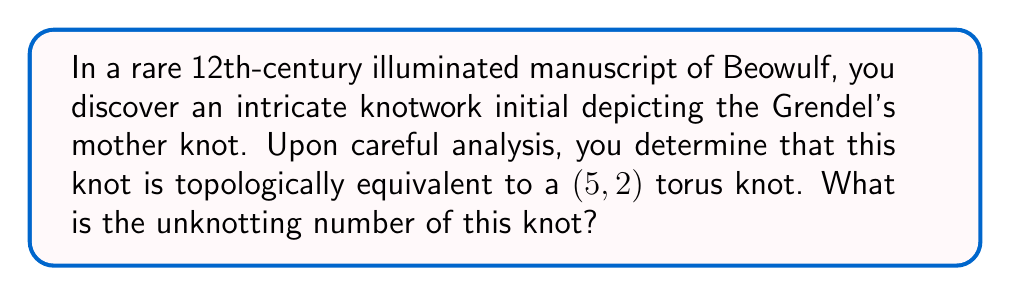Teach me how to tackle this problem. To determine the unknotting number of the (5,2) torus knot, we'll follow these steps:

1) First, recall that for a (p,q) torus knot, where p and q are coprime integers, the unknotting number u is given by the formula:

   $$u = \frac{(p-1)(q-1)}{2}$$

2) In this case, we have p = 5 and q = 2. Let's substitute these values:

   $$u = \frac{(5-1)(2-1)}{2}$$

3) Simplify:
   $$u = \frac{(4)(1)}{2} = \frac{4}{2}$$

4) Calculate the final result:
   $$u = 2$$

5) To understand this geometrically, we can visualize that it takes two crossing changes to unknot the (5,2) torus knot. Each crossing change reduces the number of twists around the longitudinal direction of the torus.

[asy]
import graph;
size(200);
pair A=(0,0), B=(2,0), C=(1,1.5);
draw(A--B--C--cycle);
draw((0.7,0.5)--(1.3,0.5), arrow=Arrow(TeXHead));
draw((1.3,1)--(0.7,1), arrow=Arrow(TeXHead));
label("2 crossing changes", (1,1.8), N);
[/asy]

This result aligns with the general property that the unknotting number of a non-trivial torus knot is always greater than 1, reflecting the complexity found in medieval manuscript illuminations.
Answer: 2 